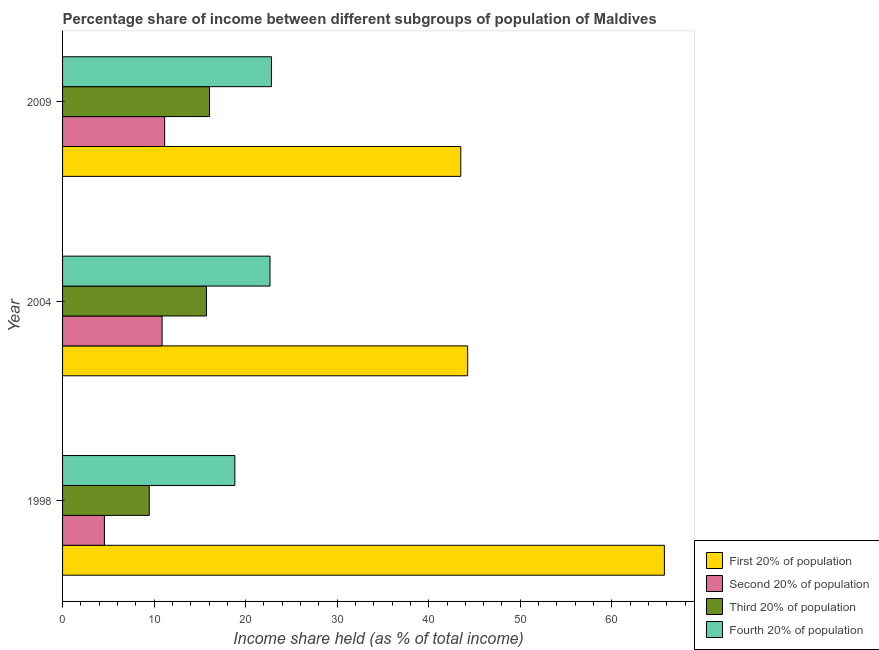How many groups of bars are there?
Offer a terse response. 3. Are the number of bars per tick equal to the number of legend labels?
Keep it short and to the point. Yes. Are the number of bars on each tick of the Y-axis equal?
Offer a terse response. Yes. What is the label of the 2nd group of bars from the top?
Provide a succinct answer. 2004. What is the share of the income held by third 20% of the population in 1998?
Offer a terse response. 9.47. Across all years, what is the maximum share of the income held by fourth 20% of the population?
Your answer should be compact. 22.82. Across all years, what is the minimum share of the income held by third 20% of the population?
Make the answer very short. 9.47. In which year was the share of the income held by second 20% of the population minimum?
Your answer should be compact. 1998. What is the total share of the income held by third 20% of the population in the graph?
Your answer should be very brief. 41.24. What is the difference between the share of the income held by first 20% of the population in 1998 and that in 2004?
Make the answer very short. 21.49. What is the difference between the share of the income held by second 20% of the population in 2009 and the share of the income held by first 20% of the population in 1998?
Offer a very short reply. -54.59. What is the average share of the income held by third 20% of the population per year?
Your answer should be compact. 13.75. In the year 2004, what is the difference between the share of the income held by second 20% of the population and share of the income held by fourth 20% of the population?
Make the answer very short. -11.79. In how many years, is the share of the income held by third 20% of the population greater than 42 %?
Keep it short and to the point. 0. What is the ratio of the share of the income held by first 20% of the population in 1998 to that in 2004?
Offer a terse response. 1.49. Is the share of the income held by second 20% of the population in 2004 less than that in 2009?
Your answer should be compact. Yes. What is the difference between the highest and the second highest share of the income held by first 20% of the population?
Ensure brevity in your answer.  21.49. What is the difference between the highest and the lowest share of the income held by first 20% of the population?
Offer a very short reply. 22.24. In how many years, is the share of the income held by fourth 20% of the population greater than the average share of the income held by fourth 20% of the population taken over all years?
Your answer should be very brief. 2. Is the sum of the share of the income held by fourth 20% of the population in 1998 and 2004 greater than the maximum share of the income held by first 20% of the population across all years?
Your answer should be very brief. No. Is it the case that in every year, the sum of the share of the income held by first 20% of the population and share of the income held by fourth 20% of the population is greater than the sum of share of the income held by second 20% of the population and share of the income held by third 20% of the population?
Make the answer very short. Yes. What does the 3rd bar from the top in 1998 represents?
Offer a very short reply. Second 20% of population. What does the 3rd bar from the bottom in 1998 represents?
Give a very brief answer. Third 20% of population. How many bars are there?
Your answer should be compact. 12. What is the difference between two consecutive major ticks on the X-axis?
Your answer should be compact. 10. Are the values on the major ticks of X-axis written in scientific E-notation?
Your answer should be compact. No. Does the graph contain any zero values?
Give a very brief answer. No. Does the graph contain grids?
Provide a succinct answer. No. Where does the legend appear in the graph?
Offer a very short reply. Bottom right. What is the title of the graph?
Ensure brevity in your answer.  Percentage share of income between different subgroups of population of Maldives. What is the label or title of the X-axis?
Make the answer very short. Income share held (as % of total income). What is the label or title of the Y-axis?
Provide a short and direct response. Year. What is the Income share held (as % of total income) of First 20% of population in 1998?
Offer a terse response. 65.74. What is the Income share held (as % of total income) of Second 20% of population in 1998?
Offer a terse response. 4.57. What is the Income share held (as % of total income) of Third 20% of population in 1998?
Give a very brief answer. 9.47. What is the Income share held (as % of total income) in Fourth 20% of population in 1998?
Make the answer very short. 18.82. What is the Income share held (as % of total income) in First 20% of population in 2004?
Your answer should be compact. 44.25. What is the Income share held (as % of total income) in Second 20% of population in 2004?
Your response must be concise. 10.87. What is the Income share held (as % of total income) of Third 20% of population in 2004?
Give a very brief answer. 15.72. What is the Income share held (as % of total income) in Fourth 20% of population in 2004?
Give a very brief answer. 22.66. What is the Income share held (as % of total income) of First 20% of population in 2009?
Make the answer very short. 43.5. What is the Income share held (as % of total income) in Second 20% of population in 2009?
Keep it short and to the point. 11.15. What is the Income share held (as % of total income) in Third 20% of population in 2009?
Your answer should be compact. 16.05. What is the Income share held (as % of total income) of Fourth 20% of population in 2009?
Keep it short and to the point. 22.82. Across all years, what is the maximum Income share held (as % of total income) of First 20% of population?
Your answer should be compact. 65.74. Across all years, what is the maximum Income share held (as % of total income) in Second 20% of population?
Keep it short and to the point. 11.15. Across all years, what is the maximum Income share held (as % of total income) in Third 20% of population?
Your answer should be compact. 16.05. Across all years, what is the maximum Income share held (as % of total income) in Fourth 20% of population?
Keep it short and to the point. 22.82. Across all years, what is the minimum Income share held (as % of total income) of First 20% of population?
Your response must be concise. 43.5. Across all years, what is the minimum Income share held (as % of total income) of Second 20% of population?
Make the answer very short. 4.57. Across all years, what is the minimum Income share held (as % of total income) in Third 20% of population?
Provide a short and direct response. 9.47. Across all years, what is the minimum Income share held (as % of total income) of Fourth 20% of population?
Keep it short and to the point. 18.82. What is the total Income share held (as % of total income) in First 20% of population in the graph?
Offer a terse response. 153.49. What is the total Income share held (as % of total income) in Second 20% of population in the graph?
Provide a short and direct response. 26.59. What is the total Income share held (as % of total income) of Third 20% of population in the graph?
Keep it short and to the point. 41.24. What is the total Income share held (as % of total income) in Fourth 20% of population in the graph?
Your answer should be compact. 64.3. What is the difference between the Income share held (as % of total income) in First 20% of population in 1998 and that in 2004?
Keep it short and to the point. 21.49. What is the difference between the Income share held (as % of total income) of Third 20% of population in 1998 and that in 2004?
Your response must be concise. -6.25. What is the difference between the Income share held (as % of total income) in Fourth 20% of population in 1998 and that in 2004?
Give a very brief answer. -3.84. What is the difference between the Income share held (as % of total income) of First 20% of population in 1998 and that in 2009?
Ensure brevity in your answer.  22.24. What is the difference between the Income share held (as % of total income) in Second 20% of population in 1998 and that in 2009?
Your response must be concise. -6.58. What is the difference between the Income share held (as % of total income) of Third 20% of population in 1998 and that in 2009?
Your answer should be compact. -6.58. What is the difference between the Income share held (as % of total income) of Fourth 20% of population in 1998 and that in 2009?
Provide a succinct answer. -4. What is the difference between the Income share held (as % of total income) of Second 20% of population in 2004 and that in 2009?
Provide a succinct answer. -0.28. What is the difference between the Income share held (as % of total income) of Third 20% of population in 2004 and that in 2009?
Make the answer very short. -0.33. What is the difference between the Income share held (as % of total income) in Fourth 20% of population in 2004 and that in 2009?
Keep it short and to the point. -0.16. What is the difference between the Income share held (as % of total income) of First 20% of population in 1998 and the Income share held (as % of total income) of Second 20% of population in 2004?
Your answer should be compact. 54.87. What is the difference between the Income share held (as % of total income) in First 20% of population in 1998 and the Income share held (as % of total income) in Third 20% of population in 2004?
Provide a succinct answer. 50.02. What is the difference between the Income share held (as % of total income) in First 20% of population in 1998 and the Income share held (as % of total income) in Fourth 20% of population in 2004?
Offer a very short reply. 43.08. What is the difference between the Income share held (as % of total income) in Second 20% of population in 1998 and the Income share held (as % of total income) in Third 20% of population in 2004?
Make the answer very short. -11.15. What is the difference between the Income share held (as % of total income) of Second 20% of population in 1998 and the Income share held (as % of total income) of Fourth 20% of population in 2004?
Provide a succinct answer. -18.09. What is the difference between the Income share held (as % of total income) of Third 20% of population in 1998 and the Income share held (as % of total income) of Fourth 20% of population in 2004?
Offer a terse response. -13.19. What is the difference between the Income share held (as % of total income) in First 20% of population in 1998 and the Income share held (as % of total income) in Second 20% of population in 2009?
Your answer should be very brief. 54.59. What is the difference between the Income share held (as % of total income) in First 20% of population in 1998 and the Income share held (as % of total income) in Third 20% of population in 2009?
Give a very brief answer. 49.69. What is the difference between the Income share held (as % of total income) in First 20% of population in 1998 and the Income share held (as % of total income) in Fourth 20% of population in 2009?
Offer a very short reply. 42.92. What is the difference between the Income share held (as % of total income) in Second 20% of population in 1998 and the Income share held (as % of total income) in Third 20% of population in 2009?
Your answer should be very brief. -11.48. What is the difference between the Income share held (as % of total income) in Second 20% of population in 1998 and the Income share held (as % of total income) in Fourth 20% of population in 2009?
Offer a terse response. -18.25. What is the difference between the Income share held (as % of total income) of Third 20% of population in 1998 and the Income share held (as % of total income) of Fourth 20% of population in 2009?
Give a very brief answer. -13.35. What is the difference between the Income share held (as % of total income) in First 20% of population in 2004 and the Income share held (as % of total income) in Second 20% of population in 2009?
Provide a succinct answer. 33.1. What is the difference between the Income share held (as % of total income) in First 20% of population in 2004 and the Income share held (as % of total income) in Third 20% of population in 2009?
Keep it short and to the point. 28.2. What is the difference between the Income share held (as % of total income) in First 20% of population in 2004 and the Income share held (as % of total income) in Fourth 20% of population in 2009?
Your response must be concise. 21.43. What is the difference between the Income share held (as % of total income) of Second 20% of population in 2004 and the Income share held (as % of total income) of Third 20% of population in 2009?
Your response must be concise. -5.18. What is the difference between the Income share held (as % of total income) of Second 20% of population in 2004 and the Income share held (as % of total income) of Fourth 20% of population in 2009?
Your answer should be very brief. -11.95. What is the difference between the Income share held (as % of total income) in Third 20% of population in 2004 and the Income share held (as % of total income) in Fourth 20% of population in 2009?
Give a very brief answer. -7.1. What is the average Income share held (as % of total income) in First 20% of population per year?
Offer a terse response. 51.16. What is the average Income share held (as % of total income) in Second 20% of population per year?
Offer a very short reply. 8.86. What is the average Income share held (as % of total income) in Third 20% of population per year?
Keep it short and to the point. 13.75. What is the average Income share held (as % of total income) of Fourth 20% of population per year?
Your answer should be very brief. 21.43. In the year 1998, what is the difference between the Income share held (as % of total income) of First 20% of population and Income share held (as % of total income) of Second 20% of population?
Your answer should be very brief. 61.17. In the year 1998, what is the difference between the Income share held (as % of total income) of First 20% of population and Income share held (as % of total income) of Third 20% of population?
Keep it short and to the point. 56.27. In the year 1998, what is the difference between the Income share held (as % of total income) in First 20% of population and Income share held (as % of total income) in Fourth 20% of population?
Give a very brief answer. 46.92. In the year 1998, what is the difference between the Income share held (as % of total income) of Second 20% of population and Income share held (as % of total income) of Third 20% of population?
Your answer should be compact. -4.9. In the year 1998, what is the difference between the Income share held (as % of total income) of Second 20% of population and Income share held (as % of total income) of Fourth 20% of population?
Offer a terse response. -14.25. In the year 1998, what is the difference between the Income share held (as % of total income) of Third 20% of population and Income share held (as % of total income) of Fourth 20% of population?
Ensure brevity in your answer.  -9.35. In the year 2004, what is the difference between the Income share held (as % of total income) of First 20% of population and Income share held (as % of total income) of Second 20% of population?
Your answer should be compact. 33.38. In the year 2004, what is the difference between the Income share held (as % of total income) of First 20% of population and Income share held (as % of total income) of Third 20% of population?
Offer a terse response. 28.53. In the year 2004, what is the difference between the Income share held (as % of total income) of First 20% of population and Income share held (as % of total income) of Fourth 20% of population?
Offer a terse response. 21.59. In the year 2004, what is the difference between the Income share held (as % of total income) in Second 20% of population and Income share held (as % of total income) in Third 20% of population?
Offer a terse response. -4.85. In the year 2004, what is the difference between the Income share held (as % of total income) of Second 20% of population and Income share held (as % of total income) of Fourth 20% of population?
Make the answer very short. -11.79. In the year 2004, what is the difference between the Income share held (as % of total income) of Third 20% of population and Income share held (as % of total income) of Fourth 20% of population?
Keep it short and to the point. -6.94. In the year 2009, what is the difference between the Income share held (as % of total income) of First 20% of population and Income share held (as % of total income) of Second 20% of population?
Offer a very short reply. 32.35. In the year 2009, what is the difference between the Income share held (as % of total income) of First 20% of population and Income share held (as % of total income) of Third 20% of population?
Keep it short and to the point. 27.45. In the year 2009, what is the difference between the Income share held (as % of total income) of First 20% of population and Income share held (as % of total income) of Fourth 20% of population?
Offer a very short reply. 20.68. In the year 2009, what is the difference between the Income share held (as % of total income) in Second 20% of population and Income share held (as % of total income) in Third 20% of population?
Offer a very short reply. -4.9. In the year 2009, what is the difference between the Income share held (as % of total income) of Second 20% of population and Income share held (as % of total income) of Fourth 20% of population?
Ensure brevity in your answer.  -11.67. In the year 2009, what is the difference between the Income share held (as % of total income) in Third 20% of population and Income share held (as % of total income) in Fourth 20% of population?
Make the answer very short. -6.77. What is the ratio of the Income share held (as % of total income) of First 20% of population in 1998 to that in 2004?
Give a very brief answer. 1.49. What is the ratio of the Income share held (as % of total income) in Second 20% of population in 1998 to that in 2004?
Your answer should be compact. 0.42. What is the ratio of the Income share held (as % of total income) of Third 20% of population in 1998 to that in 2004?
Make the answer very short. 0.6. What is the ratio of the Income share held (as % of total income) of Fourth 20% of population in 1998 to that in 2004?
Ensure brevity in your answer.  0.83. What is the ratio of the Income share held (as % of total income) in First 20% of population in 1998 to that in 2009?
Provide a short and direct response. 1.51. What is the ratio of the Income share held (as % of total income) in Second 20% of population in 1998 to that in 2009?
Your response must be concise. 0.41. What is the ratio of the Income share held (as % of total income) of Third 20% of population in 1998 to that in 2009?
Your answer should be compact. 0.59. What is the ratio of the Income share held (as % of total income) of Fourth 20% of population in 1998 to that in 2009?
Offer a terse response. 0.82. What is the ratio of the Income share held (as % of total income) of First 20% of population in 2004 to that in 2009?
Your answer should be compact. 1.02. What is the ratio of the Income share held (as % of total income) of Second 20% of population in 2004 to that in 2009?
Keep it short and to the point. 0.97. What is the ratio of the Income share held (as % of total income) in Third 20% of population in 2004 to that in 2009?
Ensure brevity in your answer.  0.98. What is the ratio of the Income share held (as % of total income) in Fourth 20% of population in 2004 to that in 2009?
Ensure brevity in your answer.  0.99. What is the difference between the highest and the second highest Income share held (as % of total income) of First 20% of population?
Your response must be concise. 21.49. What is the difference between the highest and the second highest Income share held (as % of total income) of Second 20% of population?
Provide a short and direct response. 0.28. What is the difference between the highest and the second highest Income share held (as % of total income) in Third 20% of population?
Provide a short and direct response. 0.33. What is the difference between the highest and the second highest Income share held (as % of total income) of Fourth 20% of population?
Your answer should be very brief. 0.16. What is the difference between the highest and the lowest Income share held (as % of total income) of First 20% of population?
Provide a short and direct response. 22.24. What is the difference between the highest and the lowest Income share held (as % of total income) of Second 20% of population?
Offer a very short reply. 6.58. What is the difference between the highest and the lowest Income share held (as % of total income) in Third 20% of population?
Give a very brief answer. 6.58. 